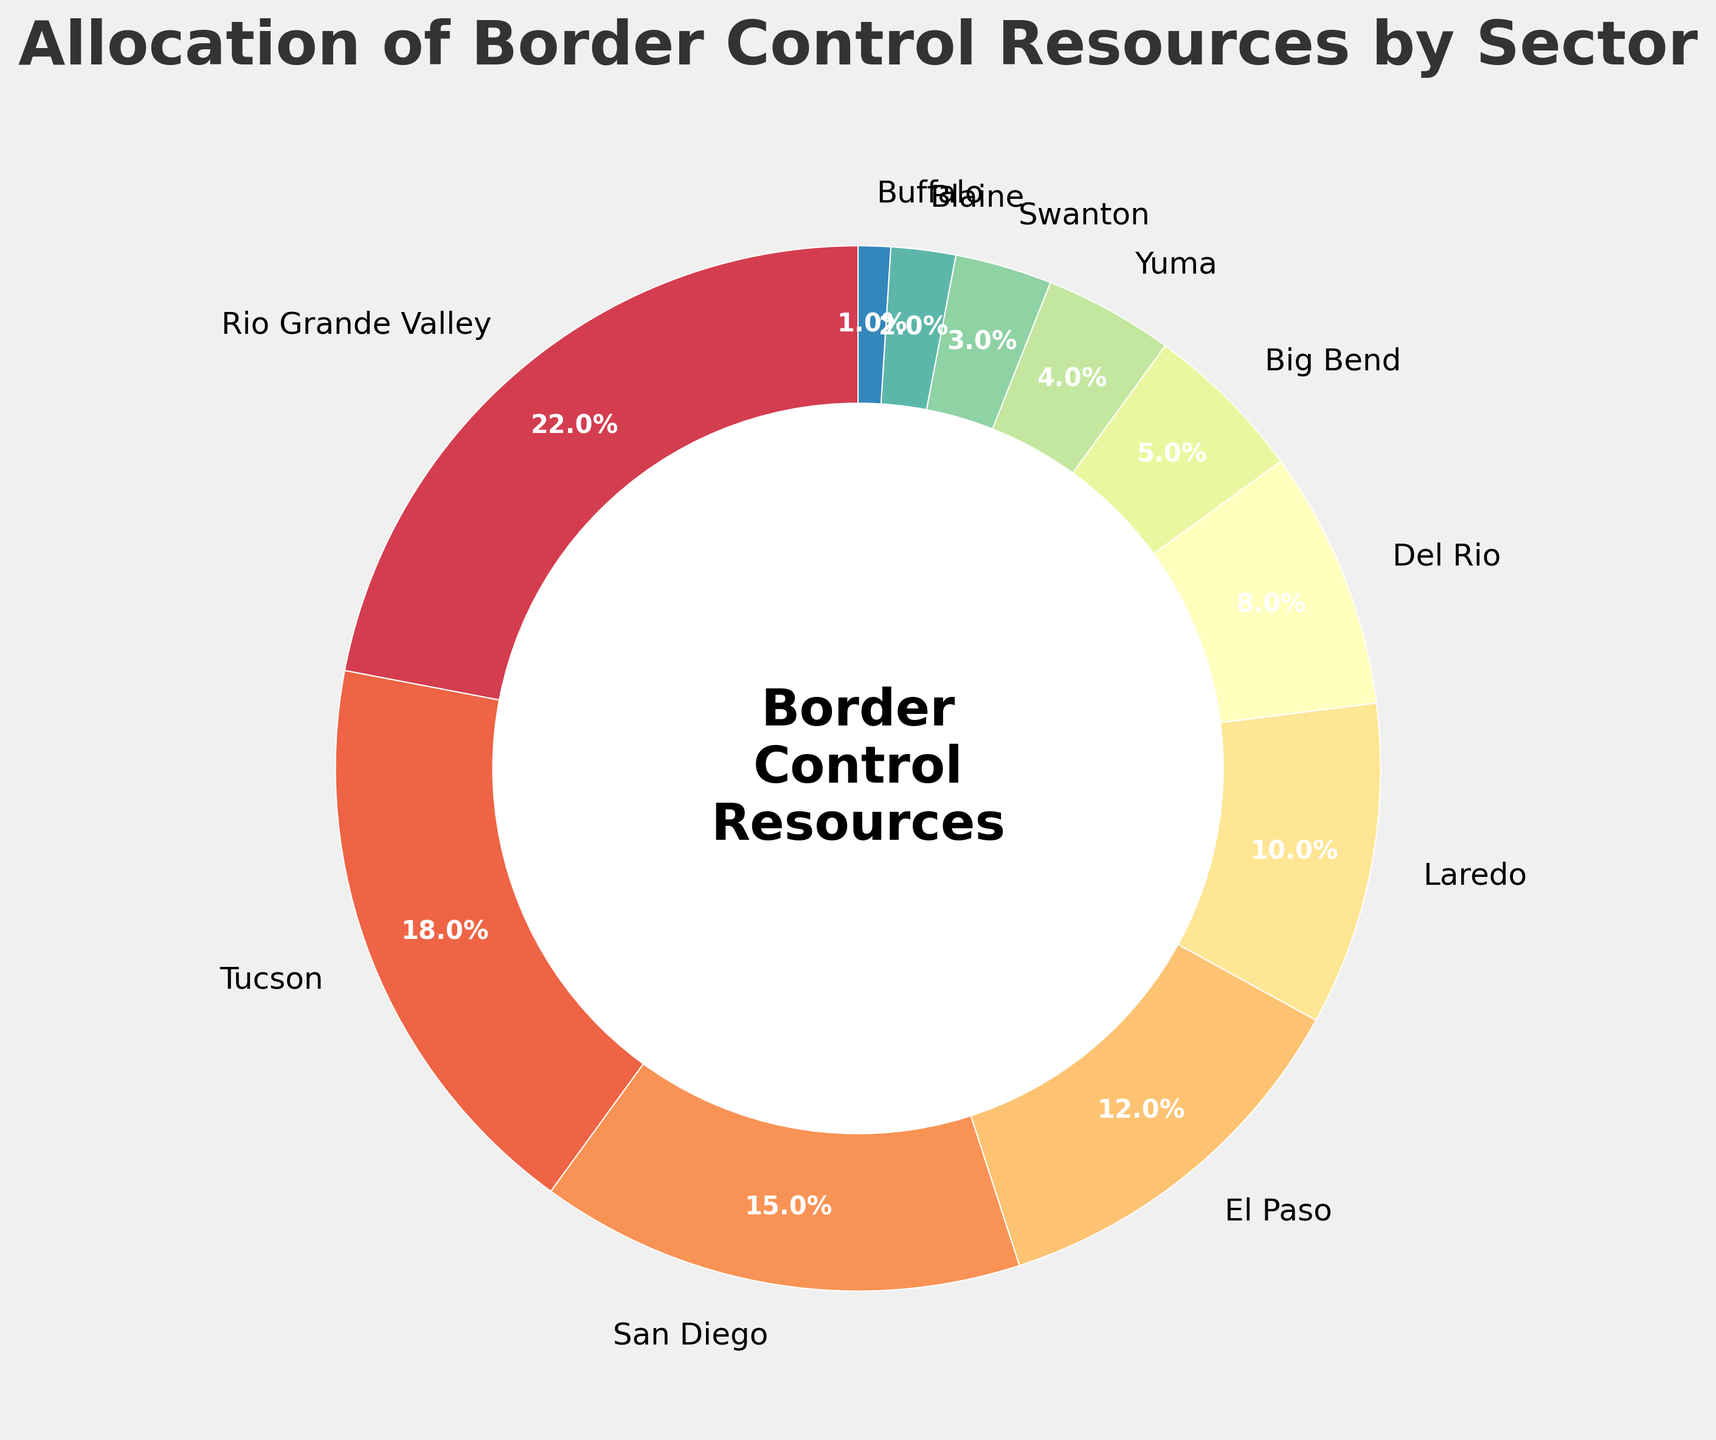What is the total budget allocation percentage for Rio Grande Valley and Tucson? The pie chart shows that Rio Grande Valley has an allocation of 22% and Tucson has 18%. Adding these two percentages together, we get 22% + 18% = 40%.
Answer: 40% What is the average allocation percentage of the sectors Blaine, Buffalo, and Swanton? The pie chart shows Blaine with 2%, Buffalo with 1%, and Swanton with 3%. To find the average, we sum these percentages and divide by the number of sectors: (2% + 1% + 3%) / 3 = 6% / 3 = 2%.
Answer: 2% What is the difference in budget allocation between Rio Grande Valley and Del Rio? The pie chart shows Rio Grande Valley with an allocation of 22% and Del Rio with 8%. The difference is calculated as 22% - 8% = 14%.
Answer: 14% How much higher is the allocation for Tucson compared to Buffalo? The pie chart shows Tucson with 18% and Buffalo with 1%. The difference is calculated as 18% - 1% = 17%.
Answer: 17% What is the combined budget allocation percentage of sectors with less than 5% allocation? The pie chart indicates that Yuma has 4%, Swanton has 3%, Blaine has 2%, and Buffalo has 1%. Summing these percentages: 4% + 3% + 2% + 1% = 10%.
Answer: 10% Which sector has the highest budget allocation percentage? By looking at the pie chart, we see that Rio Grande Valley has the highest budget allocation percentage with 22%.
Answer: Rio Grande Valley Compare the budget allocations between San Diego and El Paso. Which one has more, and by how much? San Diego has 15% allocation, and El Paso has 12%. Subtracting these, San Diego has 15% - 12% = 3% more allocation than El Paso.
Answer: San Diego by 3% Which sector receives more resources, Del Rio or Laredo? By looking at the pie chart, Laredo is allocated 10%, while Del Rio is allocated 8%. Thus, Laredo receives more resources.
Answer: Laredo Are there any sectors with equal budget allocation percentages? By examining the pie chart, no sectors have equal budget allocation percentages; each sector has a unique percentage.
Answer: No Which sector has a higher allocation, Big Bend or Yuma? According to the pie chart, Big Bend has a higher allocation with 5% compared to Yuma's 4%.
Answer: Big Bend What is the color of the wedge representing Rio Grande Valley? By looking at the pie chart, the Rio Grande Valley wedge is rendered in one of the colors within the specified color map, which visually appears close to a certain shade.
Answer: (Provide the visual color description from the plot as you see it) How does the size of the wedge for Tucson compare to San Diego's wedge visually? The pie chart visually shows that the wedge for Tucson, which is 18%, is slightly larger than the wedge for San Diego, which is 15%.
Answer: Tucson's wedge is larger What is the visual difference between the sectors with the smallest and largest wedges in terms of color and size? The pie chart shows that the smallest wedge (Buffalo) is visually smaller and likely a cooler tone compared to the largest wedge (Rio Grande Valley), which is visually larger and probably a warmer tone.
Answer: Smallest: cooler tone and small size, Largest: warmer tone and large size What visual element is placed in the center of the pie chart? The center of the pie chart has a white circle with textual elements that read "Border\nControl\nResources".
Answer: White circle with text What is the visual representation style of the border control resource allocation title? The title "Allocation of Border Control Resources by Sector" is displayed with a larger font size, bolded, and in a dark color, positioned at the top of the pie chart.
Answer: Larger, bolded, and dark-colored at the top 